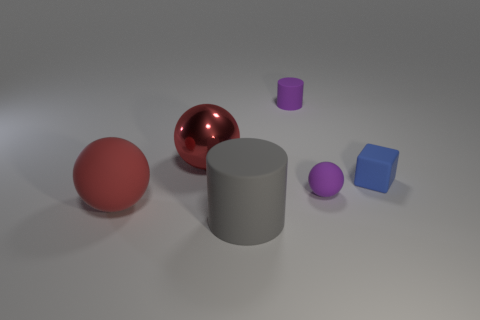Do the red ball in front of the tiny purple matte sphere and the matte ball right of the shiny ball have the same size?
Give a very brief answer. No. What number of purple things are the same material as the tiny blue thing?
Your answer should be compact. 2. What number of balls are on the right side of the matte cylinder that is in front of the rubber sphere that is on the left side of the large gray matte thing?
Provide a succinct answer. 1. Is the shape of the large red matte thing the same as the red shiny thing?
Provide a succinct answer. Yes. Are there any large red metal things that have the same shape as the blue matte object?
Provide a short and direct response. No. There is a red metallic object that is the same size as the gray matte cylinder; what shape is it?
Make the answer very short. Sphere. What material is the big thing that is behind the thing that is on the left side of the large red object behind the blue block made of?
Ensure brevity in your answer.  Metal. Do the red metal sphere and the matte block have the same size?
Your answer should be compact. No. What material is the big gray cylinder?
Keep it short and to the point. Rubber. What is the material of the tiny ball that is the same color as the tiny cylinder?
Offer a very short reply. Rubber. 